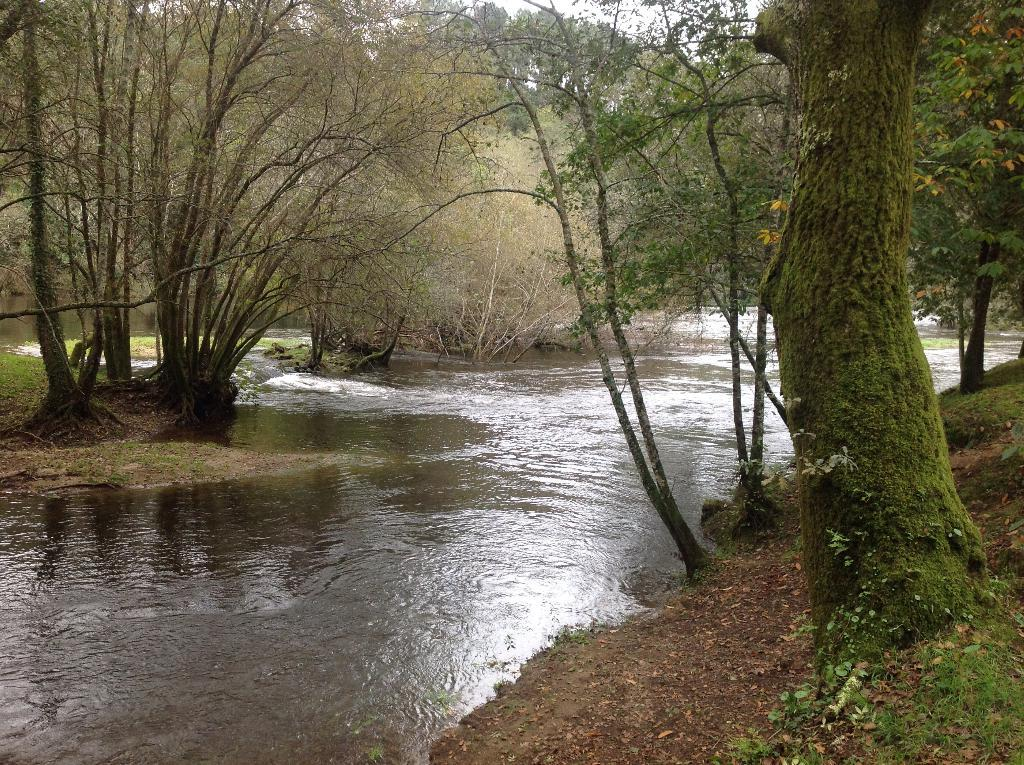What is the main subject in the center of the image? There is water in the center of the image. What can be seen in the background of the image? There are trees in the background of the image. What type of surface is at the bottom of the image? There is soil at the bottom of the image. What is the condition of the war in the image? There is no war present in the image; it features water, trees, and soil. What is the limit of the image? The image does not have a limit; it is a static representation of the scene. 